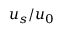Convert formula to latex. <formula><loc_0><loc_0><loc_500><loc_500>u _ { s } / u _ { 0 }</formula> 